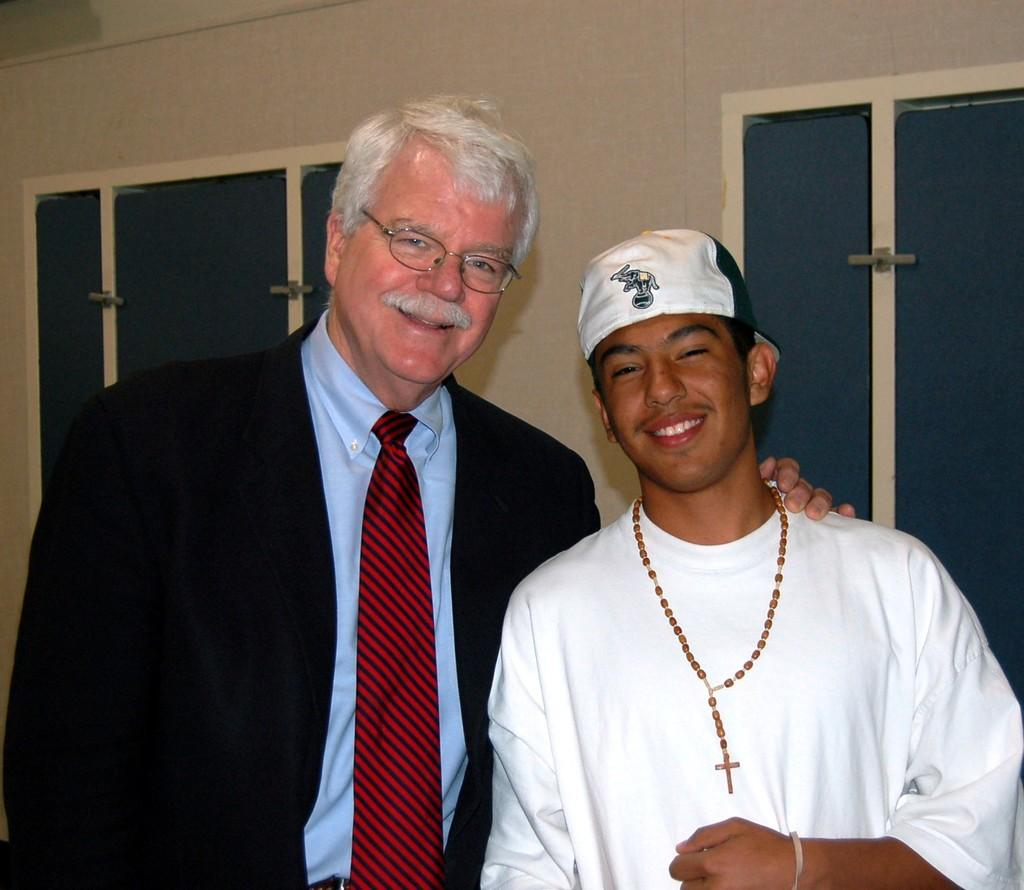How many people are in the image? There are two people in the image. What is the facial expression of the people in the image? The people are smiling. What can be seen in the background of the image? There is a wall and windows in the background of the image. What song is being sung by the kittens in the image? There are no kittens present in the image, and therefore no singing can be observed. 